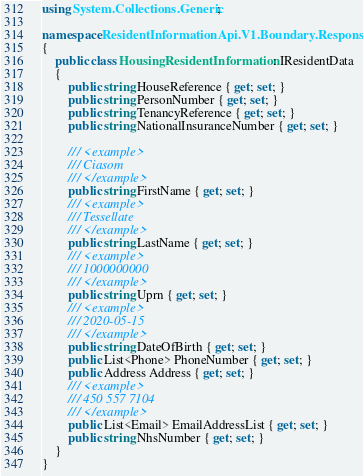Convert code to text. <code><loc_0><loc_0><loc_500><loc_500><_C#_>using System.Collections.Generic;

namespace ResidentInformationApi.V1.Boundary.Responses
{
    public class HousingResidentInformation : IResidentData
    {
        public string HouseReference { get; set; }
        public string PersonNumber { get; set; }
        public string TenancyReference { get; set; }
        public string NationalInsuranceNumber { get; set; }

        /// <example>
        /// Ciasom
        /// </example>
        public string FirstName { get; set; }
        /// <example>
        /// Tessellate
        /// </example>
        public string LastName { get; set; }
        /// <example>
        /// 1000000000
        /// </example>
        public string Uprn { get; set; }
        /// <example>
        /// 2020-05-15
        /// </example>
        public string DateOfBirth { get; set; }
        public List<Phone> PhoneNumber { get; set; }
        public Address Address { get; set; }
        /// <example>
        /// 450 557 7104
        /// </example>
        public List<Email> EmailAddressList { get; set; }
        public string NhsNumber { get; set; }
    }
}
</code> 